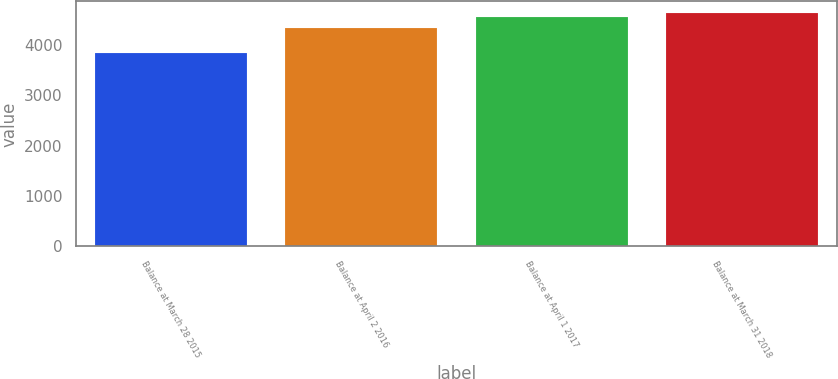<chart> <loc_0><loc_0><loc_500><loc_500><bar_chart><fcel>Balance at March 28 2015<fcel>Balance at April 2 2016<fcel>Balance at April 1 2017<fcel>Balance at March 31 2018<nl><fcel>3848.3<fcel>4348.7<fcel>4563.9<fcel>4637.17<nl></chart> 